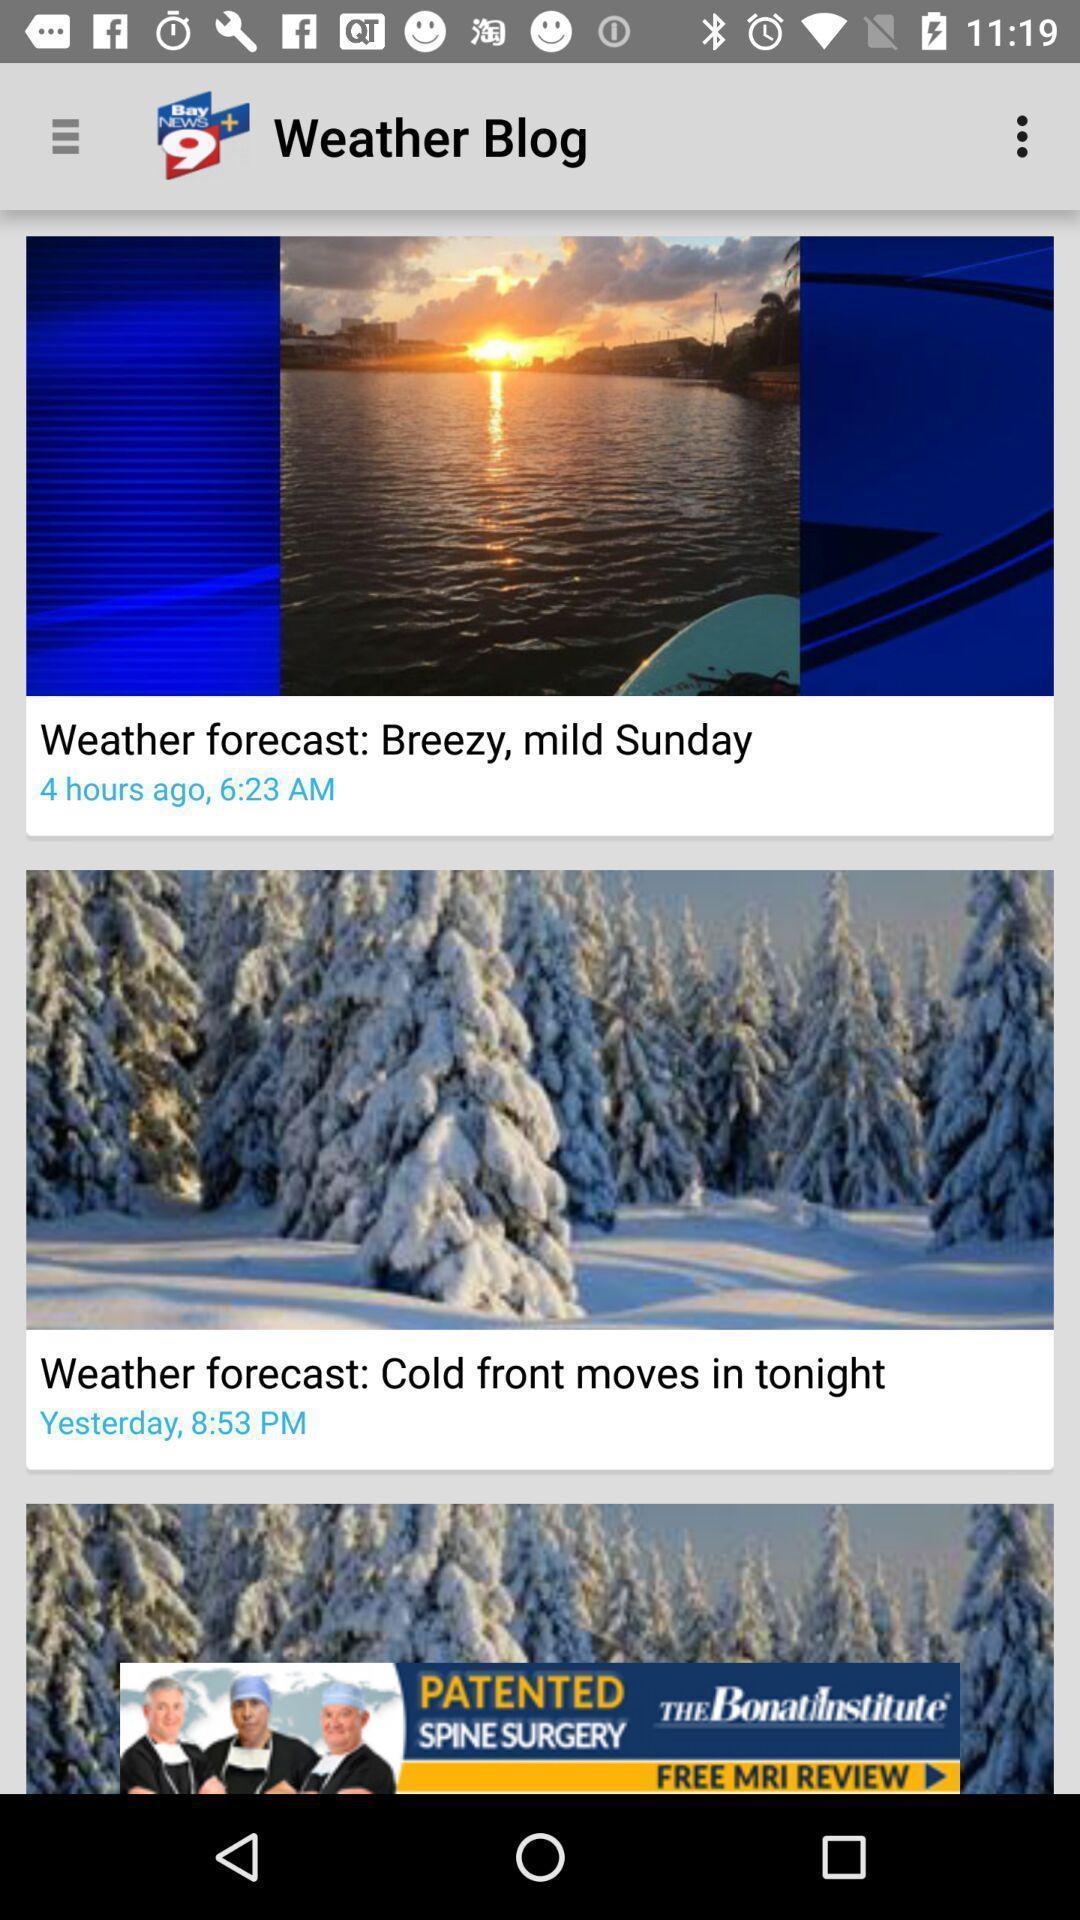Describe the content in this image. Page showing various weather blog. 